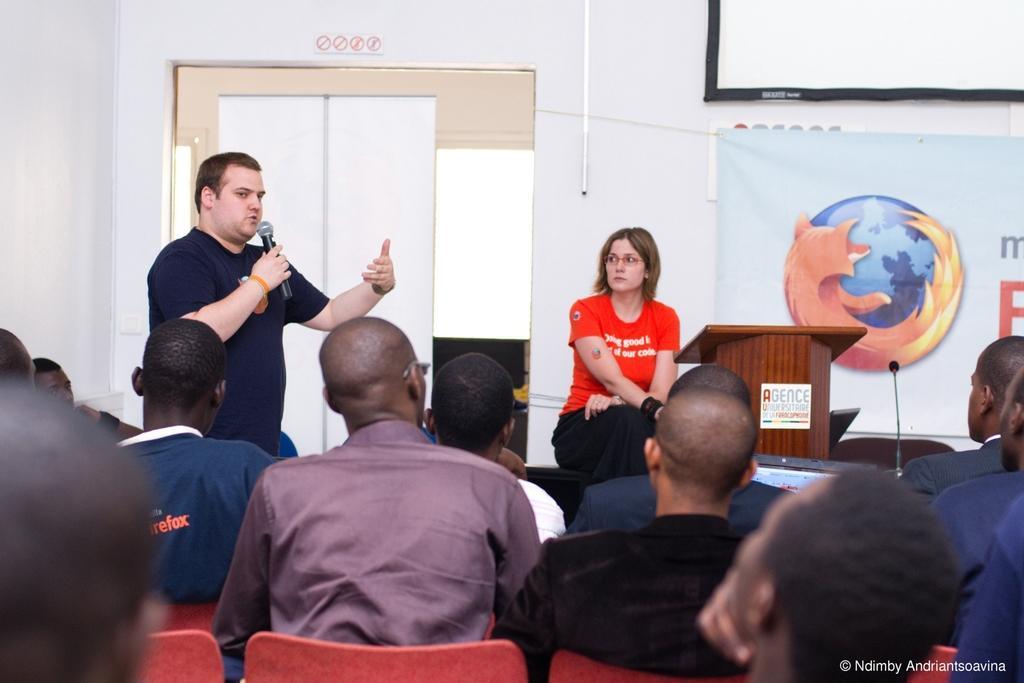Could you give a brief overview of what you see in this image? In this picture there is a person standing and holding the microphone and he is talking and there is a woman sitting. In the foreground there are group of people sitting on the chairs. At the back there is a door there is a podium and there is a microphone and there is a banner and there is text and there is a picture of a globe on the banner and there is a screen on the wall and there is a pipe on the wall. 